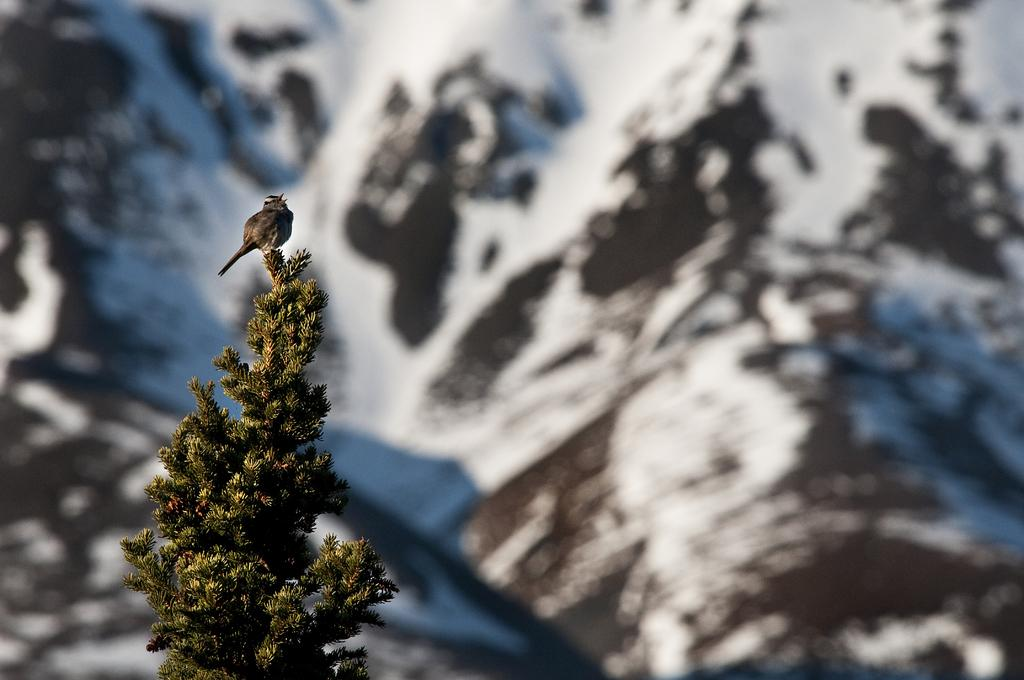What type of animal can be seen in the image? There is a bird in the image. Where is the bird located? The bird is on a tree. What other feature can be seen in the image? There is an ice hill visible in the image. What type of card is being used by the zebra in the image? There is no zebra present in the image, and therefore no card can be associated with it. 